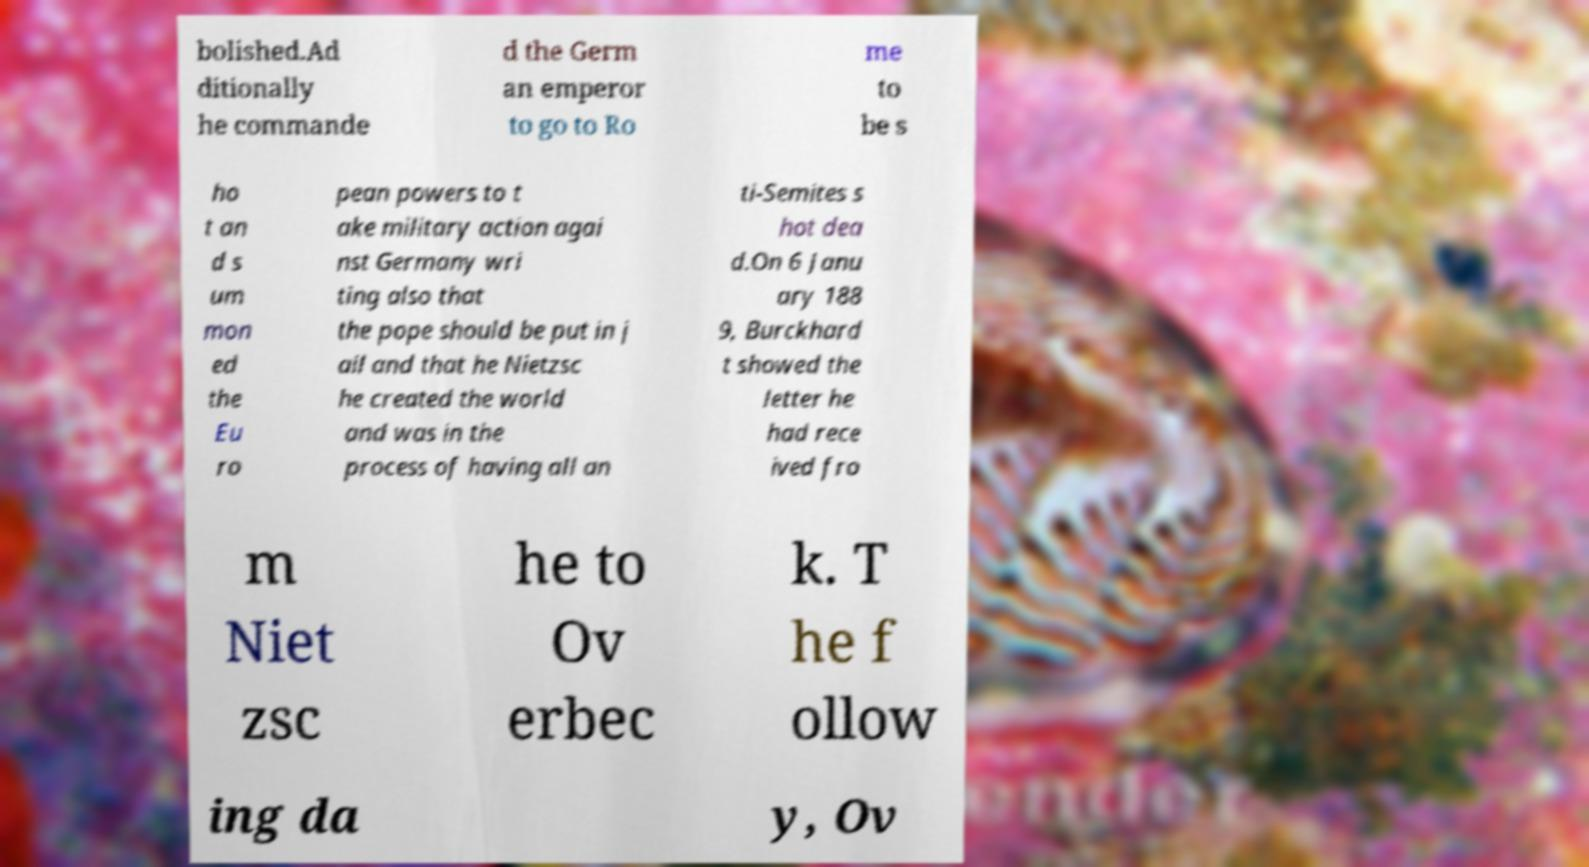Can you read and provide the text displayed in the image?This photo seems to have some interesting text. Can you extract and type it out for me? bolished.Ad ditionally he commande d the Germ an emperor to go to Ro me to be s ho t an d s um mon ed the Eu ro pean powers to t ake military action agai nst Germany wri ting also that the pope should be put in j ail and that he Nietzsc he created the world and was in the process of having all an ti-Semites s hot dea d.On 6 Janu ary 188 9, Burckhard t showed the letter he had rece ived fro m Niet zsc he to Ov erbec k. T he f ollow ing da y, Ov 